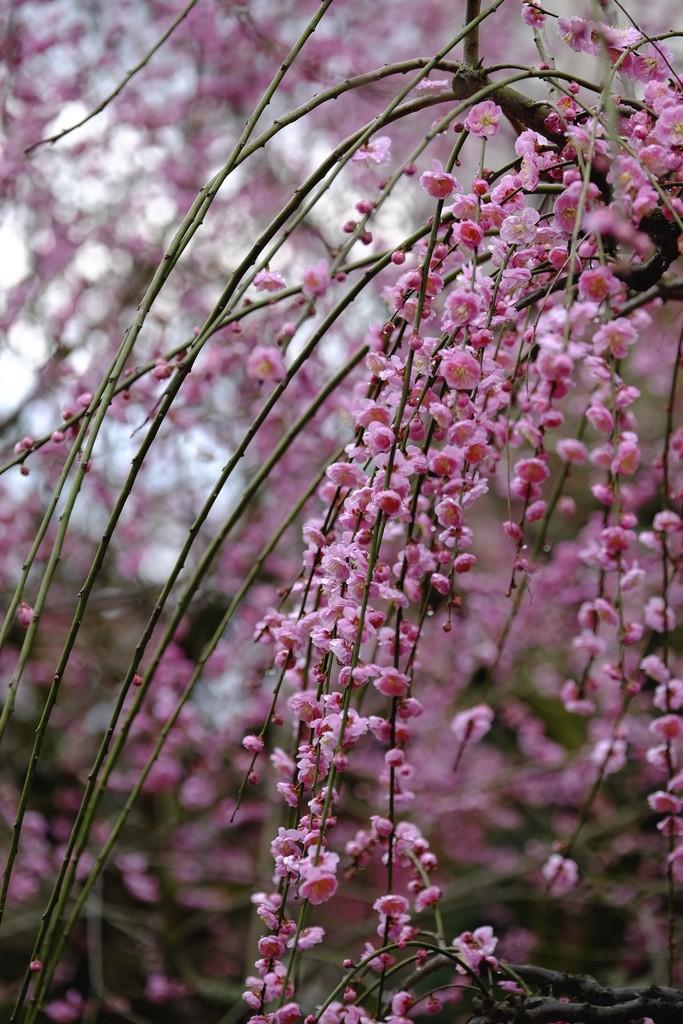How would you summarize this image in a sentence or two? This is a tree. 